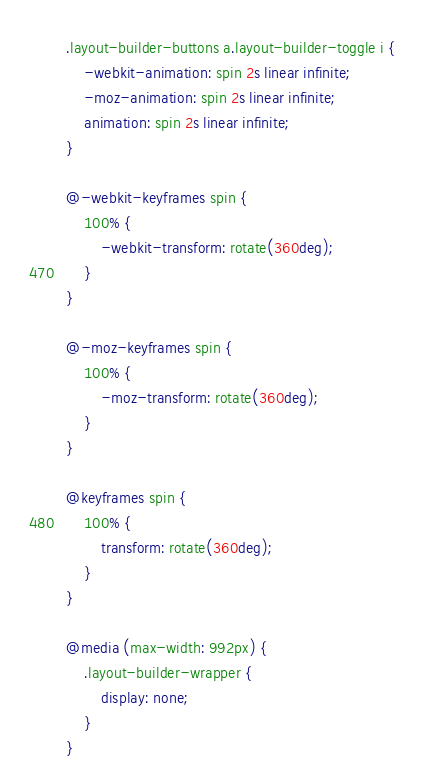<code> <loc_0><loc_0><loc_500><loc_500><_CSS_>.layout-builder-buttons a.layout-builder-toggle i {
    -webkit-animation: spin 2s linear infinite;
    -moz-animation: spin 2s linear infinite;
    animation: spin 2s linear infinite;
}

@-webkit-keyframes spin {
    100% {
        -webkit-transform: rotate(360deg);
    }
}

@-moz-keyframes spin {
    100% {
        -moz-transform: rotate(360deg);
    }
}

@keyframes spin {
    100% {
        transform: rotate(360deg);
    }
}

@media (max-width: 992px) {
    .layout-builder-wrapper {
        display: none;
    }
}
</code> 